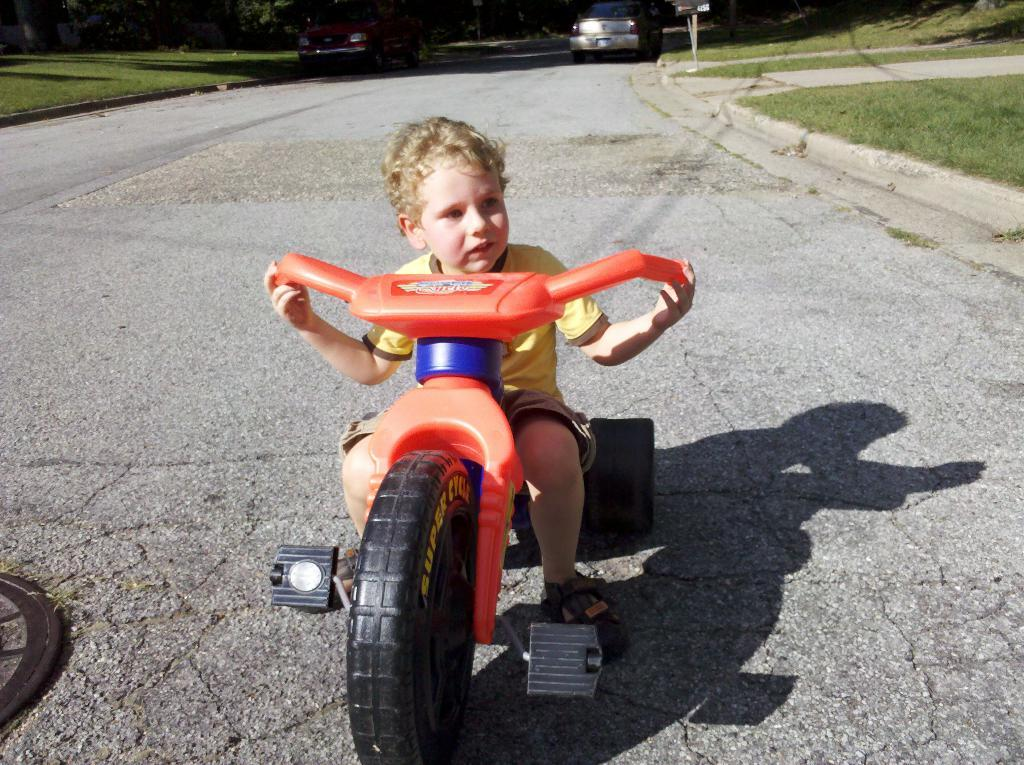What is the boy doing in the image? The boy is sitting on a vehicle in the image. What else can be seen in the image besides the boy? There are other vehicles visible in the image. What type of natural environment is present in the image? There is grass in the image. What object can be seen standing upright in the image? There is a pole in the image. What type of beef is being served at the picnic in the image? There is no picnic or beef present in the image; it features a boy sitting on a vehicle, other vehicles, grass, and a pole. 